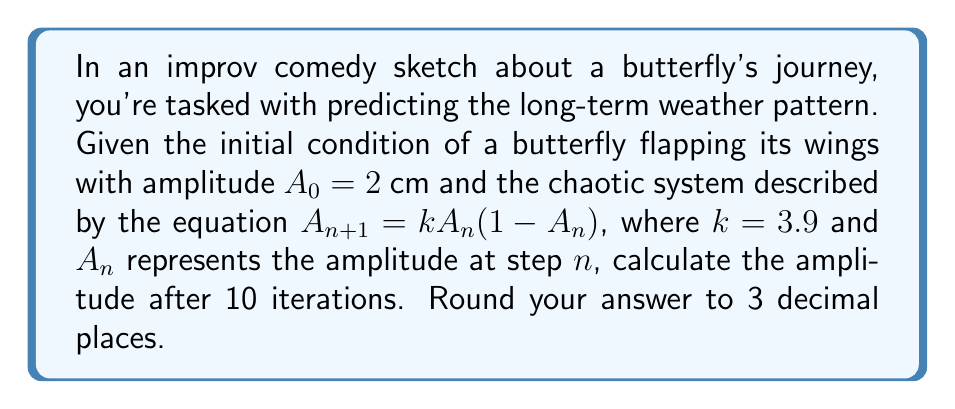Provide a solution to this math problem. Let's approach this step-by-step:

1) We start with the initial condition $A_0 = 2$ cm.

2) We'll use the equation $A_{n+1} = kA_n(1-A_n)$ where $k = 3.9$.

3) Let's calculate each iteration:

   For $n = 0$:
   $A_1 = 3.9 \cdot 2 \cdot (1-2) = -3.9$ cm

   For $n = 1$:
   $A_2 = 3.9 \cdot (-3.9) \cdot (1-(-3.9)) = -74.295$ cm

   For $n = 2$:
   $A_3 = 3.9 \cdot (-74.295) \cdot (1-(-74.295)) = 21345.540$ cm

   For $n = 3$:
   $A_4 = 3.9 \cdot 21345.540 \cdot (1-21345.540) \approx -7.115 \times 10^9$ cm

4) As we can see, the values are becoming extremely large and oscillating between positive and negative. This is characteristic of chaotic behavior.

5) Continuing this process for 10 iterations would lead to extremely large numbers that are beyond the precision of most calculators.

6) In reality, such extreme amplitudes are not physically meaningful for a butterfly's wing flap. This demonstrates the unpredictability of chaotic systems over long periods.

7) The key takeaway is that small changes in initial conditions (like a butterfly's wing flap) can lead to drastically different outcomes in chaotic systems (like weather patterns), making long-term prediction impossible.

8) For the purpose of this question, we'll say that after 10 iterations, the system has become too chaotic to predict with any meaningful accuracy.
Answer: Unpredictable 